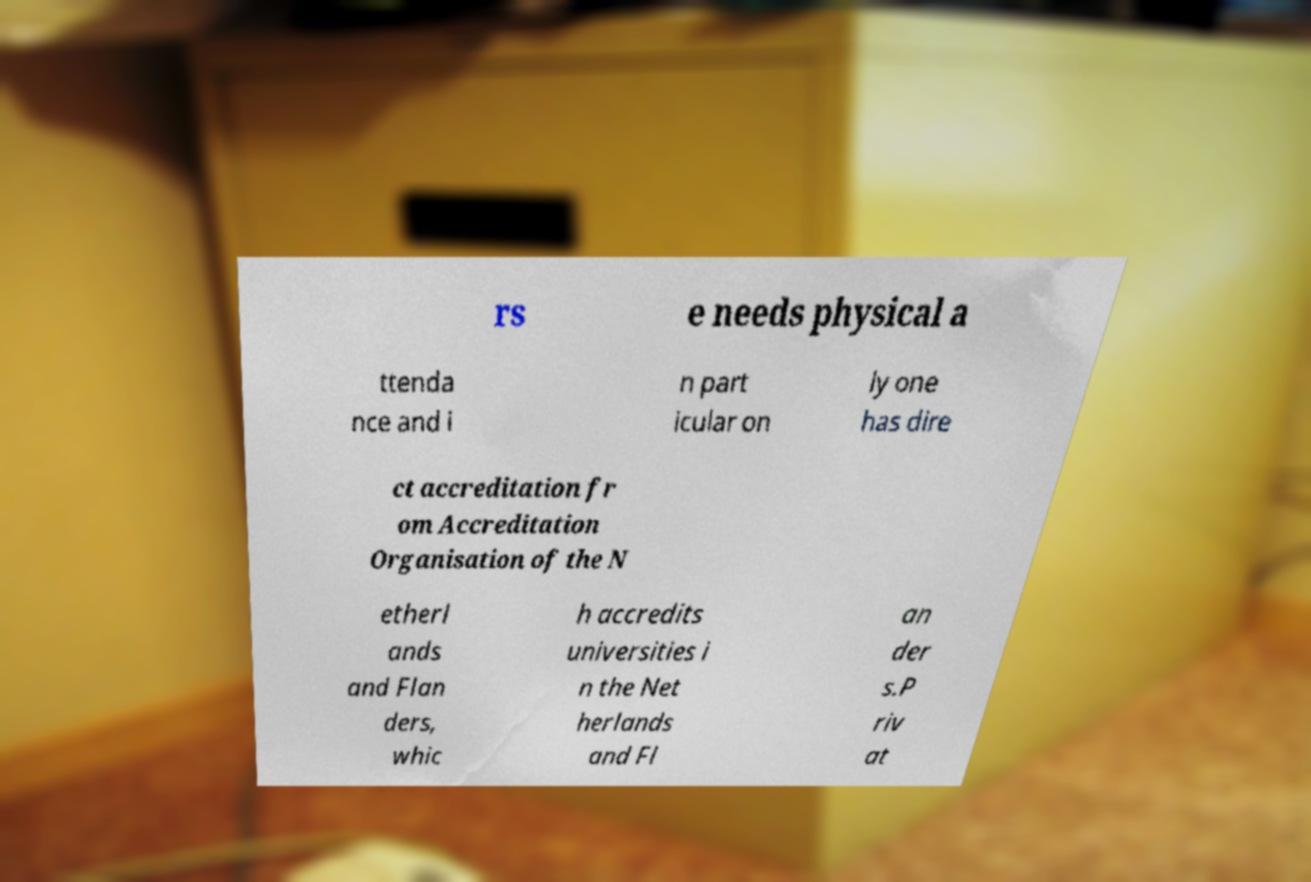Please read and relay the text visible in this image. What does it say? rs e needs physical a ttenda nce and i n part icular on ly one has dire ct accreditation fr om Accreditation Organisation of the N etherl ands and Flan ders, whic h accredits universities i n the Net herlands and Fl an der s.P riv at 